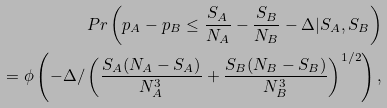<formula> <loc_0><loc_0><loc_500><loc_500>P r \left ( p _ { A } - p _ { B } \leq \frac { S _ { A } } { N _ { A } } - \frac { S _ { B } } { N _ { B } } - \Delta | S _ { A } , S _ { B } \right ) \\ = \phi \left ( - \Delta / \left ( \frac { S _ { A } ( N _ { A } - S _ { A } ) } { N _ { A } ^ { 3 } } + \frac { S _ { B } ( N _ { B } - S _ { B } ) } { N _ { B } ^ { 3 } } \right ) ^ { 1 / 2 } \right ) ,</formula> 